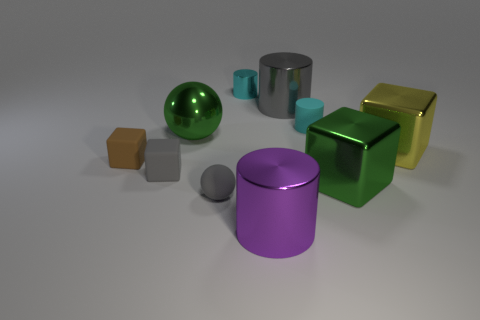Is there a small sphere right of the gray object that is right of the cyan metal object?
Your answer should be very brief. No. What material is the big sphere?
Your answer should be compact. Metal. There is a yellow cube; are there any big yellow metal things left of it?
Keep it short and to the point. No. What is the size of the gray thing that is the same shape as the cyan shiny thing?
Offer a terse response. Large. Is the number of gray objects that are behind the gray cube the same as the number of shiny cylinders that are to the left of the big purple cylinder?
Give a very brief answer. Yes. What number of rubber cubes are there?
Your answer should be compact. 2. Are there more gray objects to the left of the small brown cube than tiny red cylinders?
Provide a succinct answer. No. What is the material of the green thing that is on the left side of the cyan metal thing?
Offer a terse response. Metal. What color is the other large object that is the same shape as the purple object?
Provide a short and direct response. Gray. What number of objects have the same color as the small rubber cylinder?
Ensure brevity in your answer.  1. 